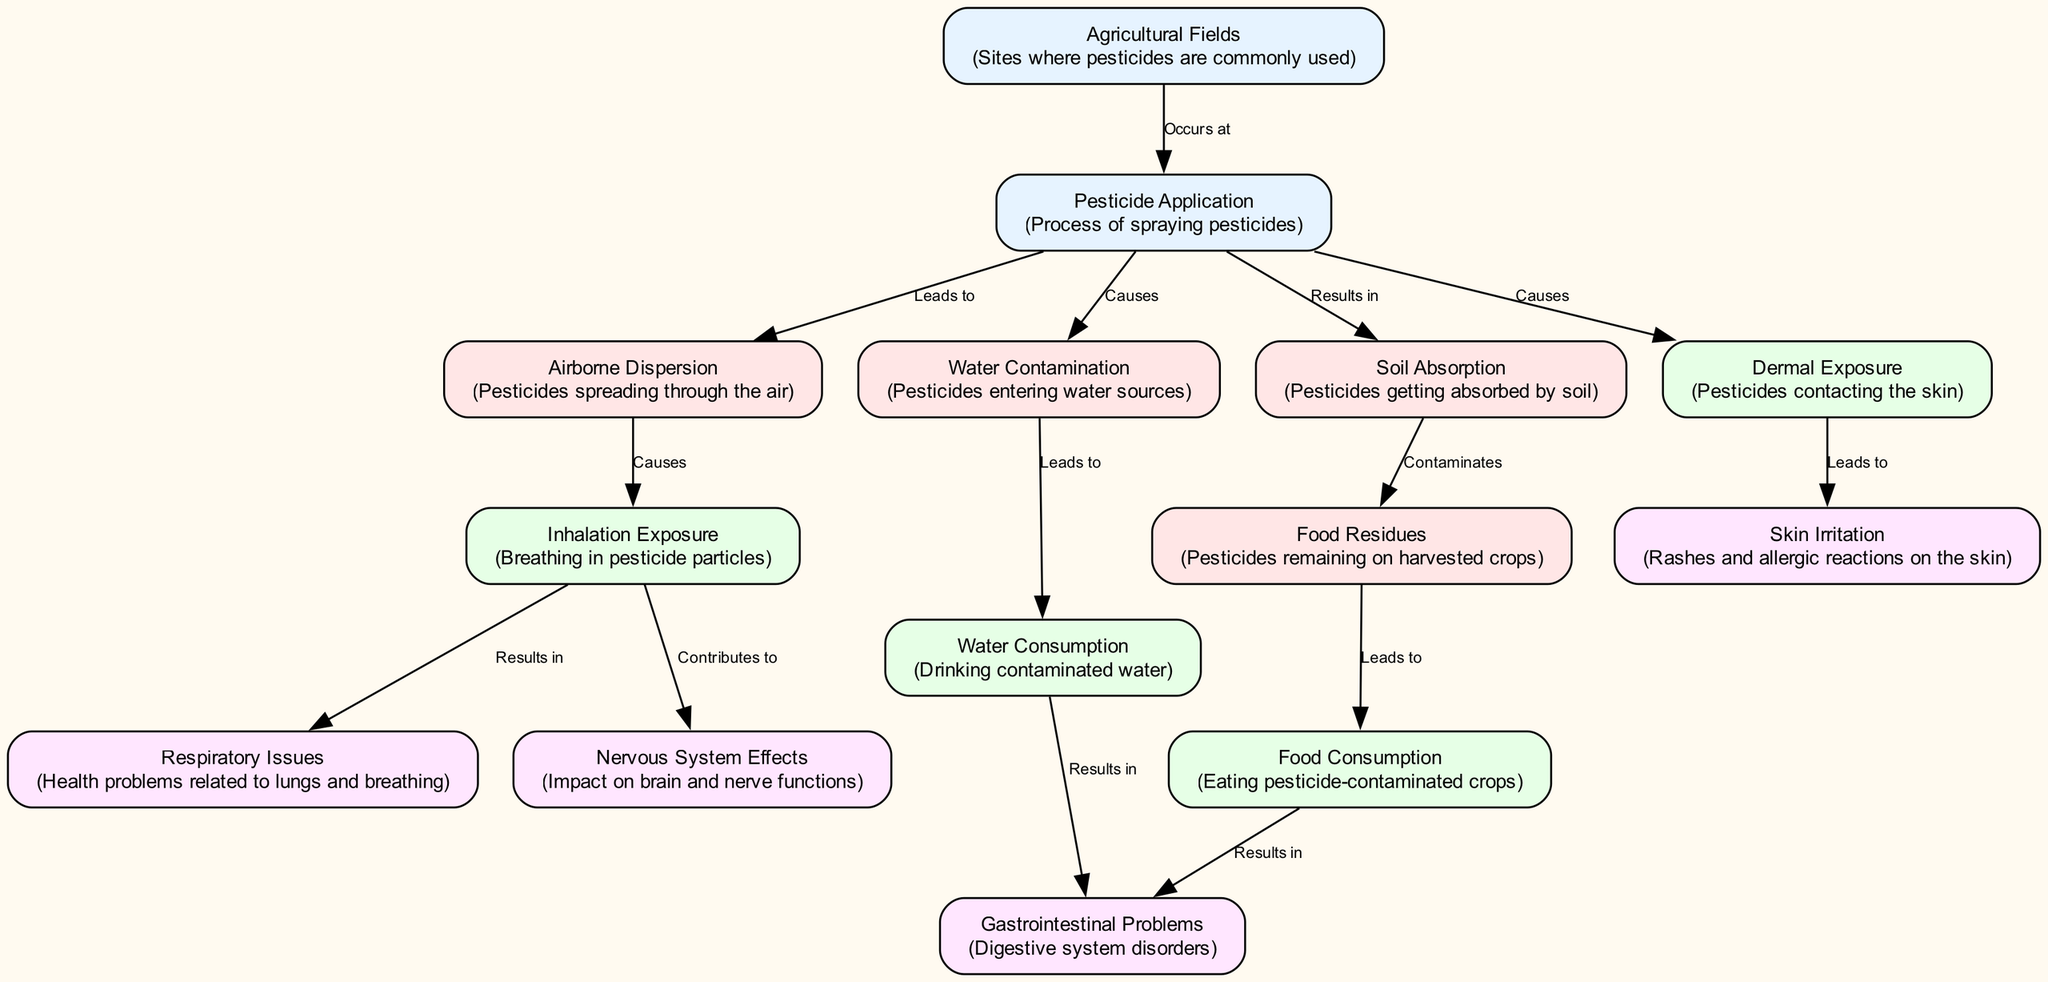What is the first node in the diagram? The first node listed in the data is "Agricultural Fields," which is typically where pesticides are applied.
Answer: Agricultural Fields How many nodes are in the diagram? By counting the nodes in the provided data, there are a total of 14 nodes representing different aspects of pesticide effects on human health.
Answer: 14 Which node is linked to "Pesticide Application"? The node directly linked to "Pesticide Application" in the diagram is "Airborne Dispersion," which represents one of the pathways that pesticides take after application.
Answer: Airborne Dispersion What type of exposure does "Inhalation Exposure" cause? "Inhalation Exposure" leads to "Respiratory Issues," indicating that breathing in pesticide particles can adversely affect lung and breathing health.
Answer: Respiratory Issues What are the two pathways that result from "Pesticide Application"? The two pathways resulting from "Pesticide Application" are "Airborne Dispersion" and "Water Contamination," showing how pesticides disseminate into the environment.
Answer: Airborne Dispersion, Water Contamination What health issue is caused by water consumption? The health issue caused by "Water Consumption" is "Gastrointestinal Problems," indicating that drinking contaminated water can lead to issues in the digestive system.
Answer: Gastrointestinal Problems How does "Food Residues" affect human health? "Food Residues" leads to "Food Consumption," which can expose individuals to pesticide-contaminated crops, posing health risks.
Answer: Food Consumption Which exposure method contributes to "Nervous System Effects"? "Inhalation Exposure" contributes to "Nervous System Effects," indicating that breathing in pesticide particles can impact neural functions.
Answer: Inhalation Exposure What is the relationship between "Soil Absorption" and "Food Residues"? "Soil Absorption" contaminates "Food Residues," showing that pesticides absorbed by the soil can remain on the harvested crops.
Answer: Contaminates 